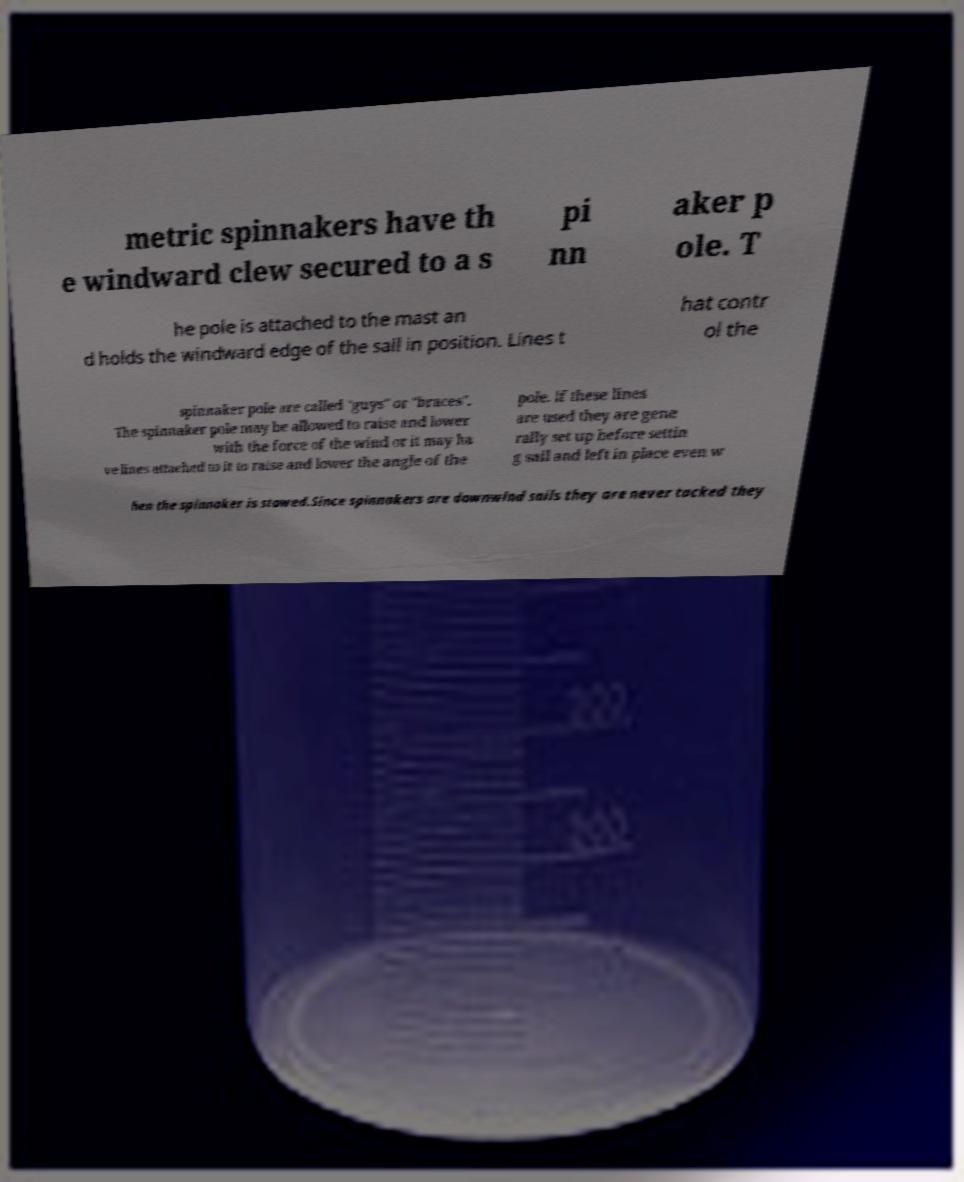There's text embedded in this image that I need extracted. Can you transcribe it verbatim? metric spinnakers have th e windward clew secured to a s pi nn aker p ole. T he pole is attached to the mast an d holds the windward edge of the sail in position. Lines t hat contr ol the spinnaker pole are called "guys" or "braces". The spinnaker pole may be allowed to raise and lower with the force of the wind or it may ha ve lines attached to it to raise and lower the angle of the pole. If these lines are used they are gene rally set up before settin g sail and left in place even w hen the spinnaker is stowed.Since spinnakers are downwind sails they are never tacked they 